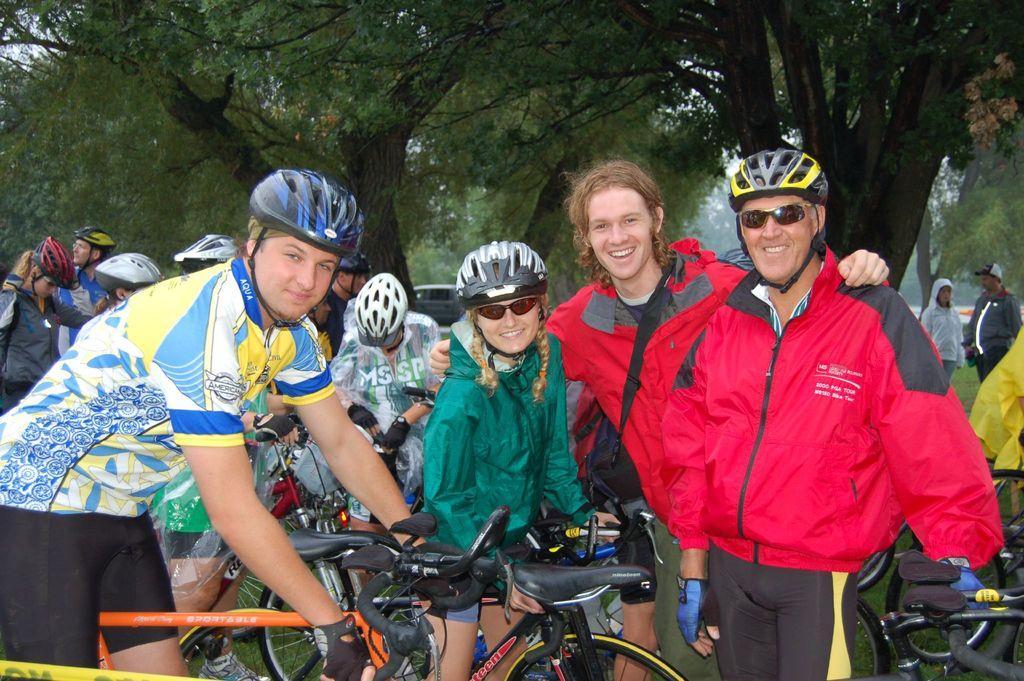How would you summarize this image in a sentence or two? In this picture we can see there are some people standing and some people are holding the bicycles. Behind the people there are trees and a sky. 